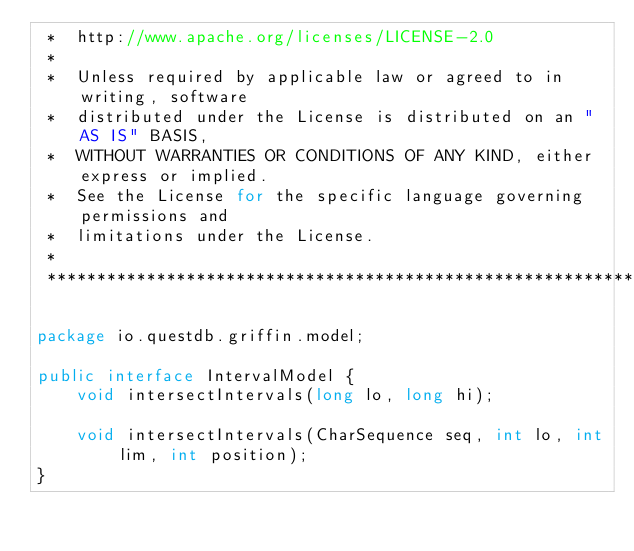Convert code to text. <code><loc_0><loc_0><loc_500><loc_500><_Java_> *  http://www.apache.org/licenses/LICENSE-2.0
 *
 *  Unless required by applicable law or agreed to in writing, software
 *  distributed under the License is distributed on an "AS IS" BASIS,
 *  WITHOUT WARRANTIES OR CONDITIONS OF ANY KIND, either express or implied.
 *  See the License for the specific language governing permissions and
 *  limitations under the License.
 *
 ******************************************************************************/

package io.questdb.griffin.model;

public interface IntervalModel {
    void intersectIntervals(long lo, long hi);

    void intersectIntervals(CharSequence seq, int lo, int lim, int position);
}
</code> 